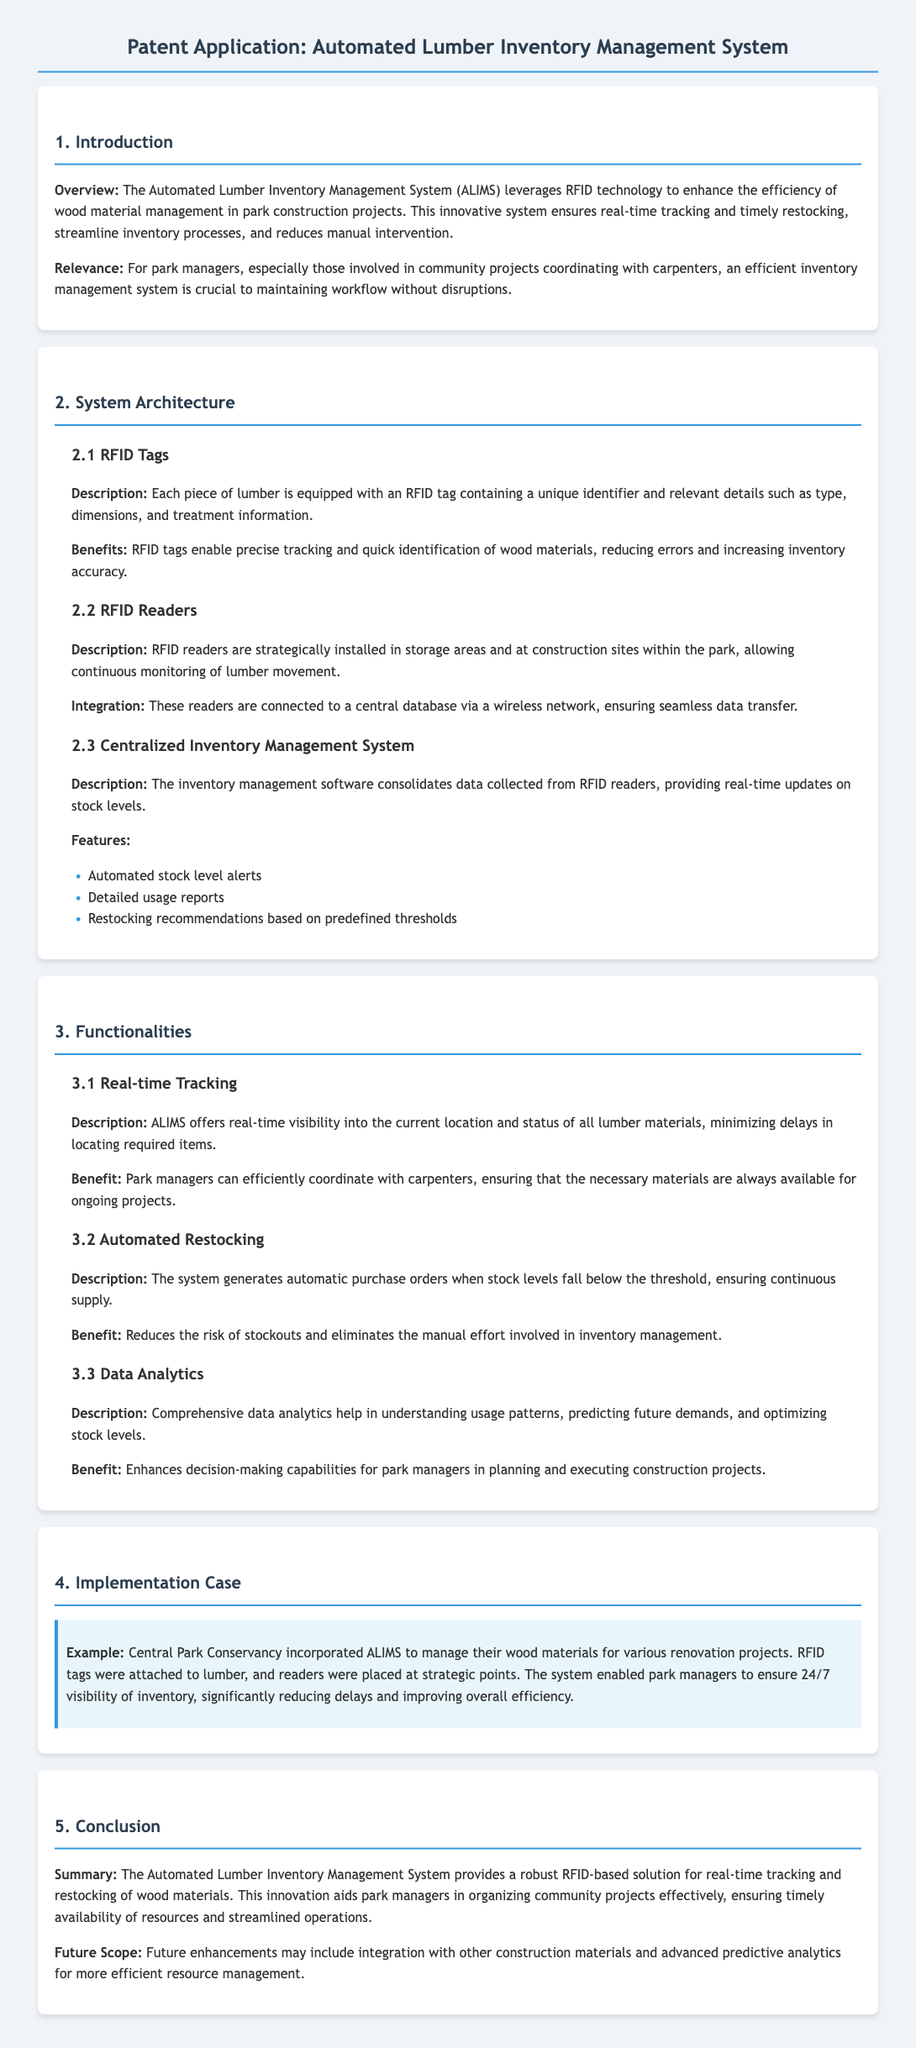What technology does the ALIMS utilize? The technology utilized by the Automated Lumber Inventory Management System is RFID (Radio-Frequency Identification).
Answer: RFID What is the primary benefit of RFID tags? RFID tags enable precise tracking and quick identification of wood materials, reducing errors and increasing inventory accuracy.
Answer: Inventory accuracy What does the inventory management software provide? The inventory management software consolidates data collected from RFID readers and provides real-time updates on stock levels.
Answer: Real-time updates What happens when stock levels fall below the threshold? The system generates automatic purchase orders to ensure continuous supply when stock levels fall below the threshold.
Answer: Automatic purchase orders Which park conservancy implemented the ALIMS as a case study? The example provided in the document mentions the Central Park Conservancy implementing ALIMS for renovation projects.
Answer: Central Park Conservancy What does the data analytics feature help with? Comprehensive data analytics help in understanding usage patterns, predicting future demands, and optimizing stock levels.
Answer: Usage patterns How does the ALIMS improve decision-making? It enhances decision-making capabilities for park managers in planning and executing construction projects through data analytics.
Answer: Data analytics What is the future scope mentioned for ALIMS? Future enhancements may include integration with other construction materials and advanced predictive analytics for more efficient resource management.
Answer: Integration with other materials What is the main purpose of ALIMS? The main purpose of the Automated Lumber Inventory Management System is to provide a robust RFID-based solution for real-time tracking and restocking of wood materials.
Answer: Real-time tracking and restocking 